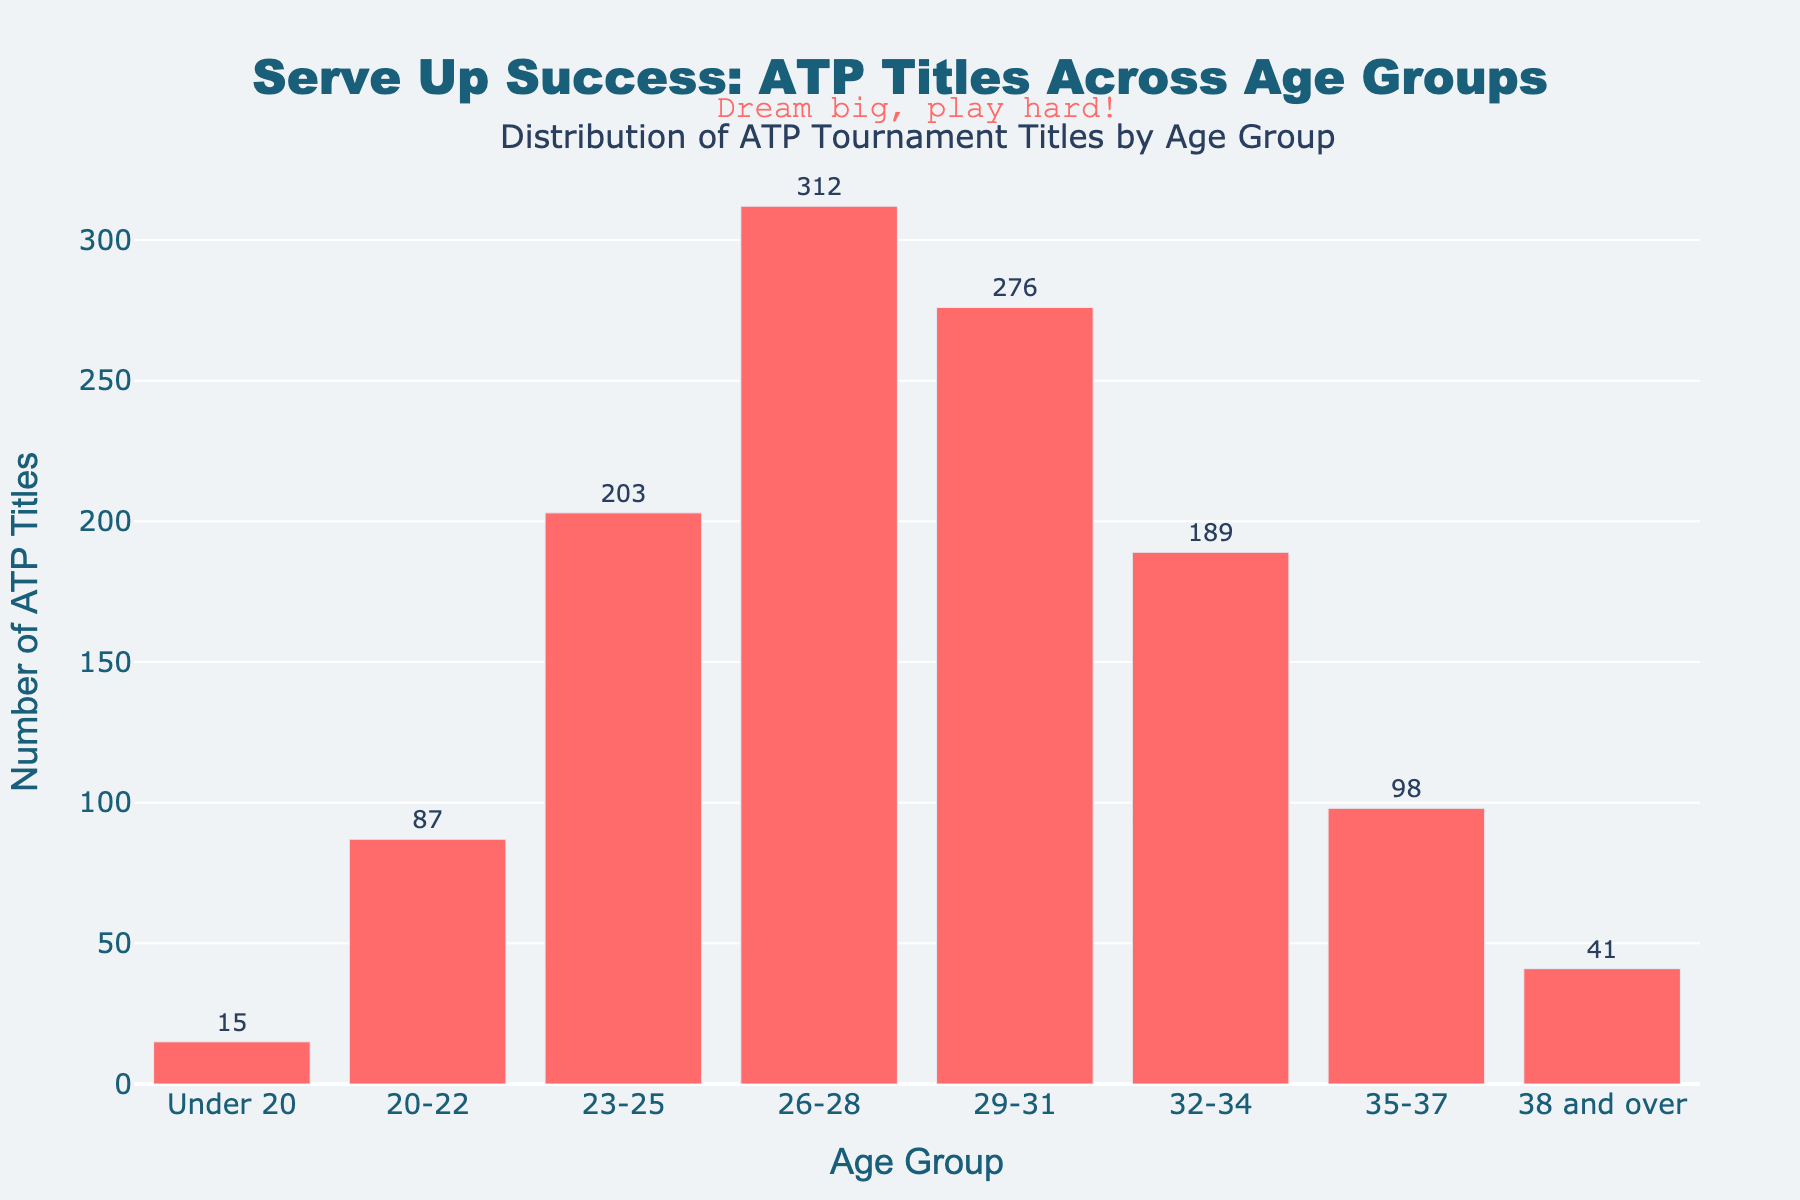What's the total number of ATP titles won by players aged 23-28? Sum the titles for the age groups 23-25 and 26-28: 203 + 312 = 515
Answer: 515 Which age group has won the most ATP titles? The age group 26-28 has the highest bar with 312 titles, indicating it has won the most ATP titles.
Answer: 26-28 Which age group has won fewer ATP titles: under 20 or 38 and over? Compare the values of the bars: under 20 has 15 titles and 38 and over has 41.
Answer: Under 20 How many more ATP titles have the 29-31 age group won compared to the 35-37 age group? Subtract the titles of the 35-37 age group from the 29-31 age group: 276 - 98 = 178
Answer: 178 What's the average number of ATP titles won by the age groups 20-22, 23-25, and 26-28? Sum the titles of the three age groups and divide by 3: (87 + 203 + 312) / 3 = 602 / 3 = 200.67
Answer: 200.67 What is the combined total of ATP titles won by players aged 32 and over? Sum the titles for the age groups 32-34, 35-37, and 38 and over: 189 + 98 + 41 = 328
Answer: 328 How many ATP titles were won by players aged under 32? Sum the titles for the age groups under 20, 20-22, 23-25, 26-28, and 29-31: 15 + 87 + 203 + 312 + 276 = 893
Answer: 893 Which two age groups combined have almost the same number of ATP titles as the 26-28 age group (312 titles)? Sum the titles of different combinations and find the pair close to 312: 203 (23-25) + 87 (20-22) = 290
Answer: 23-25 and 20-22 Which age group has the shortest bar in the graph? The shortest bar on the chart represents the under 20 age group with 15 titles.
Answer: Under 20 What’s the difference in the number of ATP titles between the age groups 20-22 and 32-34? Subtract the titles of the 20-22 age group from the 32-34 age group: 189 - 87 = 102
Answer: 102 